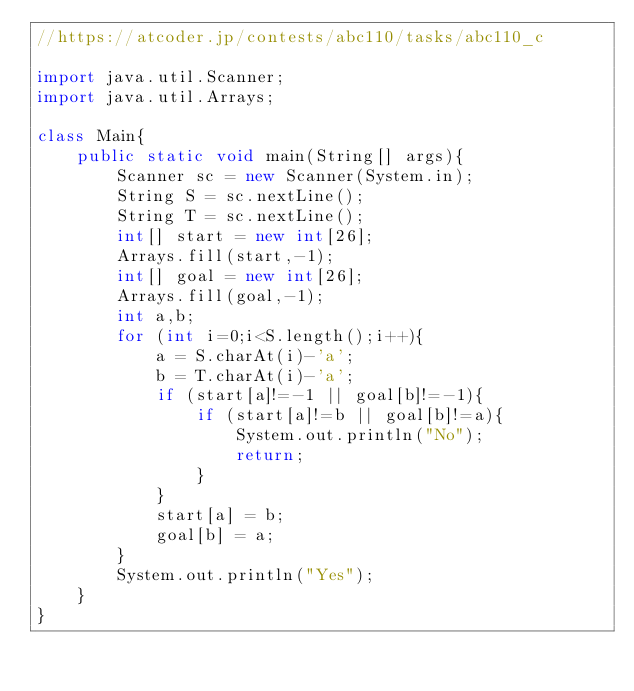<code> <loc_0><loc_0><loc_500><loc_500><_Java_>//https://atcoder.jp/contests/abc110/tasks/abc110_c

import java.util.Scanner;
import java.util.Arrays;

class Main{
    public static void main(String[] args){
        Scanner sc = new Scanner(System.in);
        String S = sc.nextLine();
        String T = sc.nextLine();
        int[] start = new int[26];
        Arrays.fill(start,-1);
        int[] goal = new int[26];
        Arrays.fill(goal,-1);
        int a,b;
        for (int i=0;i<S.length();i++){
            a = S.charAt(i)-'a';
            b = T.charAt(i)-'a';
            if (start[a]!=-1 || goal[b]!=-1){
                if (start[a]!=b || goal[b]!=a){
                    System.out.println("No");
                    return;
                }
            }
            start[a] = b;
            goal[b] = a;
        }
        System.out.println("Yes");
    }
}</code> 